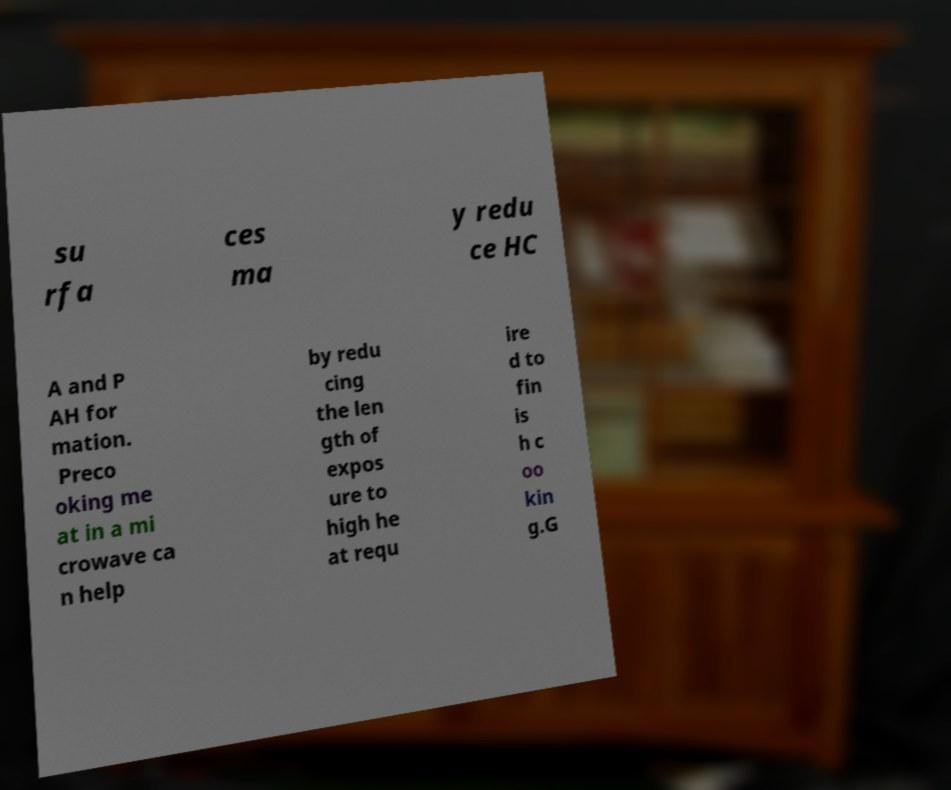Could you extract and type out the text from this image? su rfa ces ma y redu ce HC A and P AH for mation. Preco oking me at in a mi crowave ca n help by redu cing the len gth of expos ure to high he at requ ire d to fin is h c oo kin g.G 